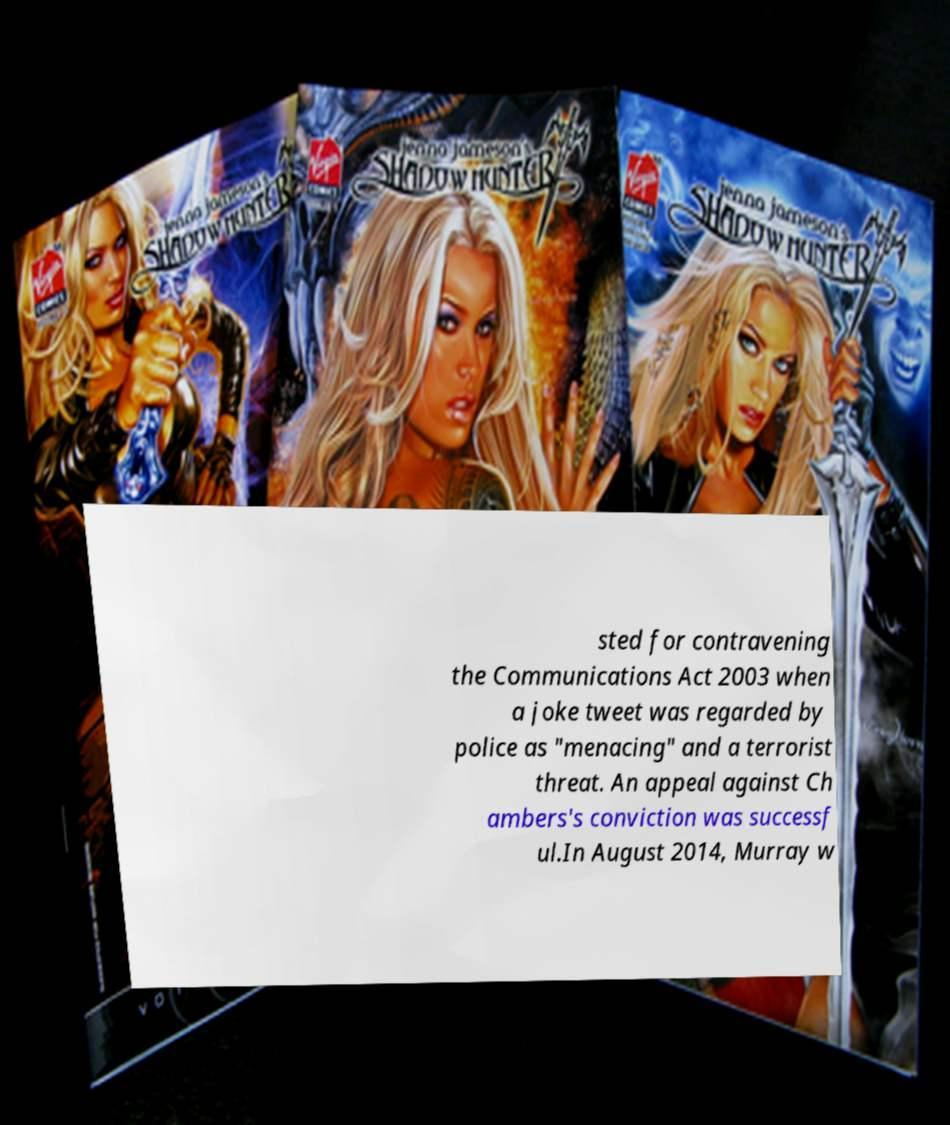There's text embedded in this image that I need extracted. Can you transcribe it verbatim? sted for contravening the Communications Act 2003 when a joke tweet was regarded by police as "menacing" and a terrorist threat. An appeal against Ch ambers's conviction was successf ul.In August 2014, Murray w 